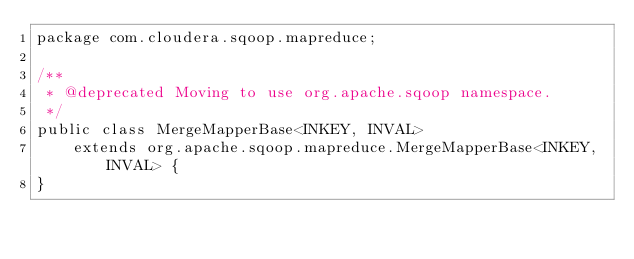<code> <loc_0><loc_0><loc_500><loc_500><_Java_>package com.cloudera.sqoop.mapreduce;

/**
 * @deprecated Moving to use org.apache.sqoop namespace.
 */
public class MergeMapperBase<INKEY, INVAL>
    extends org.apache.sqoop.mapreduce.MergeMapperBase<INKEY, INVAL> {
}
</code> 